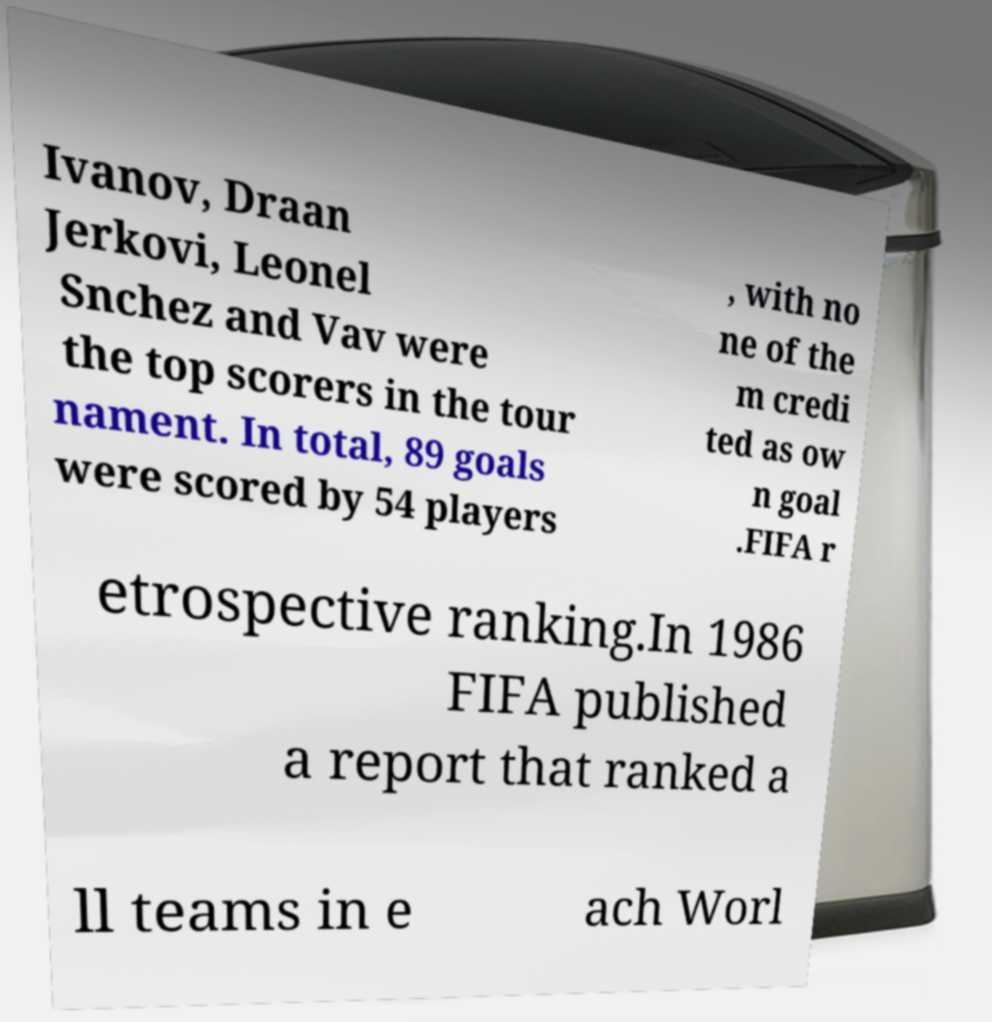Could you extract and type out the text from this image? Ivanov, Draan Jerkovi, Leonel Snchez and Vav were the top scorers in the tour nament. In total, 89 goals were scored by 54 players , with no ne of the m credi ted as ow n goal .FIFA r etrospective ranking.In 1986 FIFA published a report that ranked a ll teams in e ach Worl 